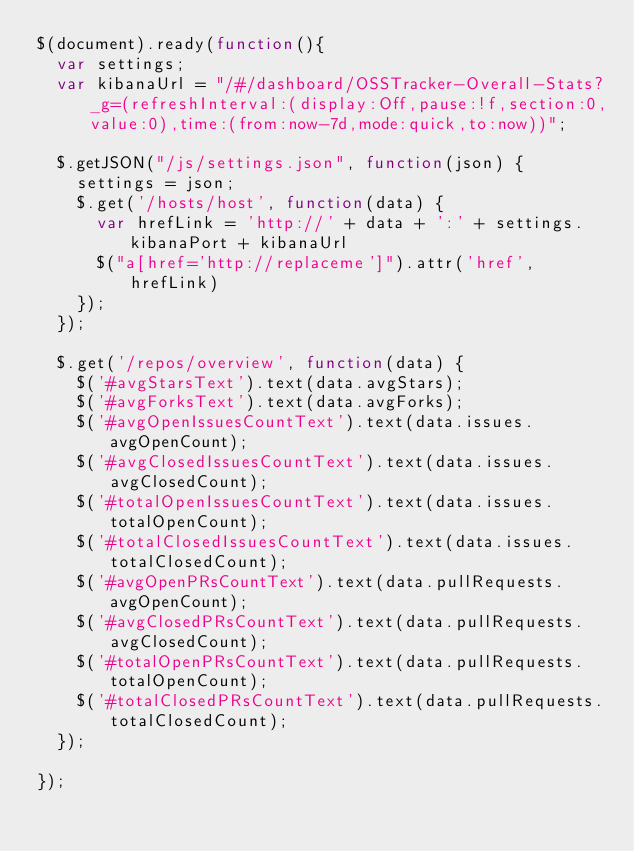Convert code to text. <code><loc_0><loc_0><loc_500><loc_500><_JavaScript_>$(document).ready(function(){
  var settings;
  var kibanaUrl = "/#/dashboard/OSSTracker-Overall-Stats?_g=(refreshInterval:(display:Off,pause:!f,section:0,value:0),time:(from:now-7d,mode:quick,to:now))";

  $.getJSON("/js/settings.json", function(json) {
    settings = json;
    $.get('/hosts/host', function(data) {
      var hrefLink = 'http://' + data + ':' + settings.kibanaPort + kibanaUrl
      $("a[href='http://replaceme']").attr('href', hrefLink)
    });
  });

  $.get('/repos/overview', function(data) {
    $('#avgStarsText').text(data.avgStars);
    $('#avgForksText').text(data.avgForks);
    $('#avgOpenIssuesCountText').text(data.issues.avgOpenCount);
    $('#avgClosedIssuesCountText').text(data.issues.avgClosedCount);
    $('#totalOpenIssuesCountText').text(data.issues.totalOpenCount);
    $('#totalClosedIssuesCountText').text(data.issues.totalClosedCount);
    $('#avgOpenPRsCountText').text(data.pullRequests.avgOpenCount);
    $('#avgClosedPRsCountText').text(data.pullRequests.avgClosedCount);
    $('#totalOpenPRsCountText').text(data.pullRequests.totalOpenCount);
    $('#totalClosedPRsCountText').text(data.pullRequests.totalClosedCount);
  });

});
</code> 